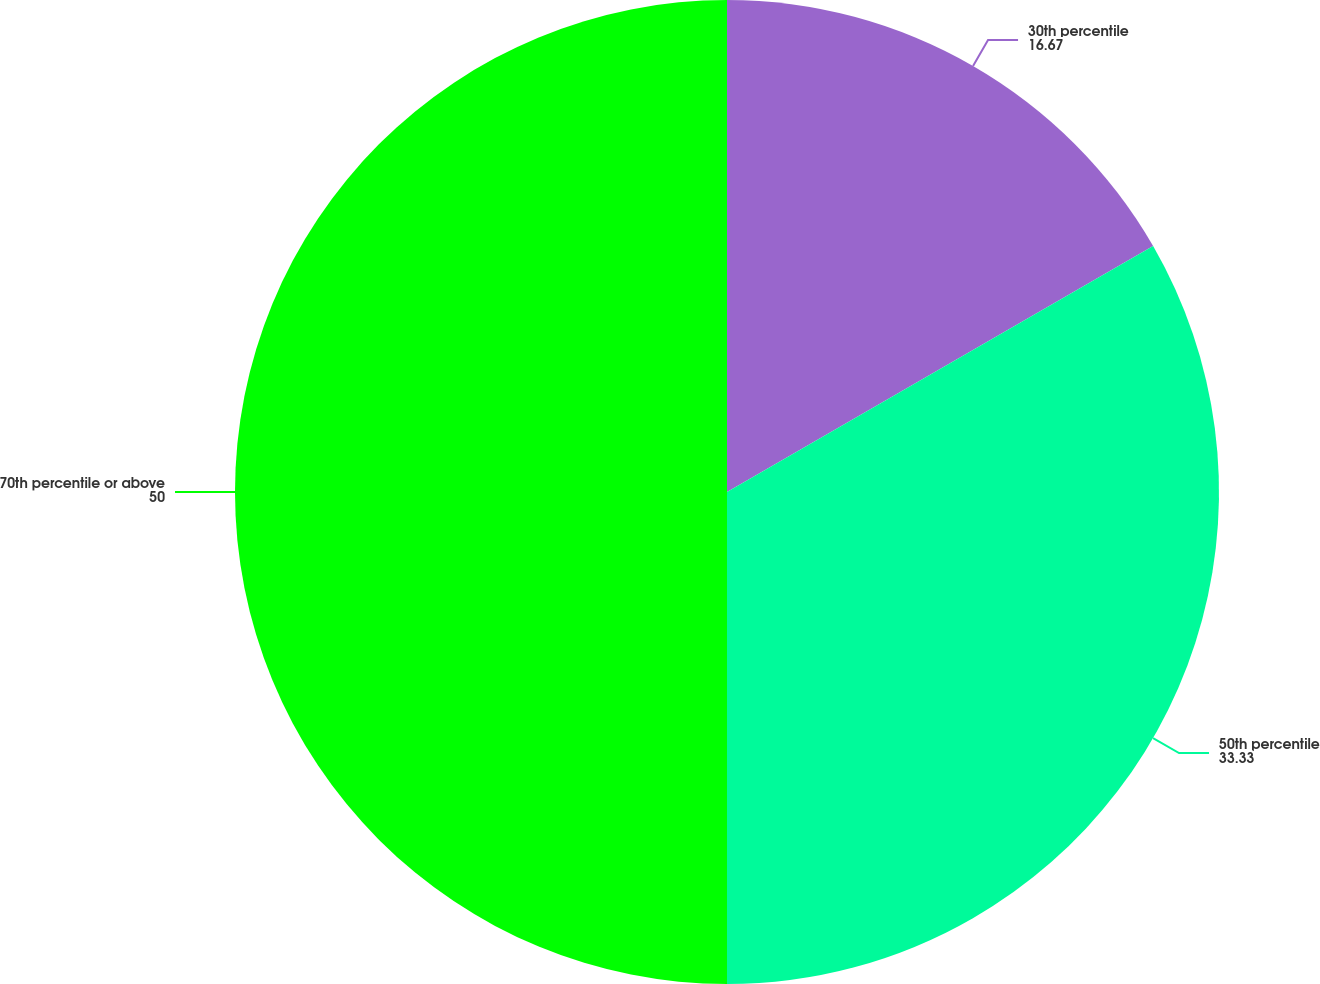Convert chart. <chart><loc_0><loc_0><loc_500><loc_500><pie_chart><fcel>30th percentile<fcel>50th percentile<fcel>70th percentile or above<nl><fcel>16.67%<fcel>33.33%<fcel>50.0%<nl></chart> 